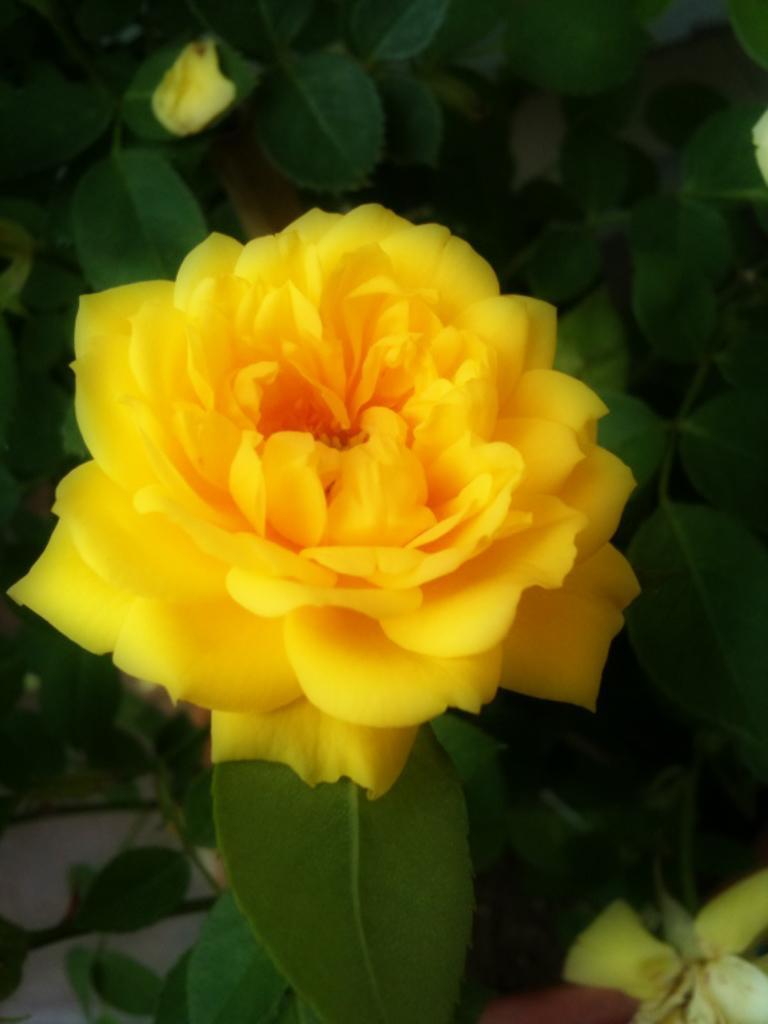Could you give a brief overview of what you see in this image? As we can see in the image there is plant and yellow color flower. 